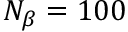<formula> <loc_0><loc_0><loc_500><loc_500>N _ { \beta } = 1 0 0</formula> 